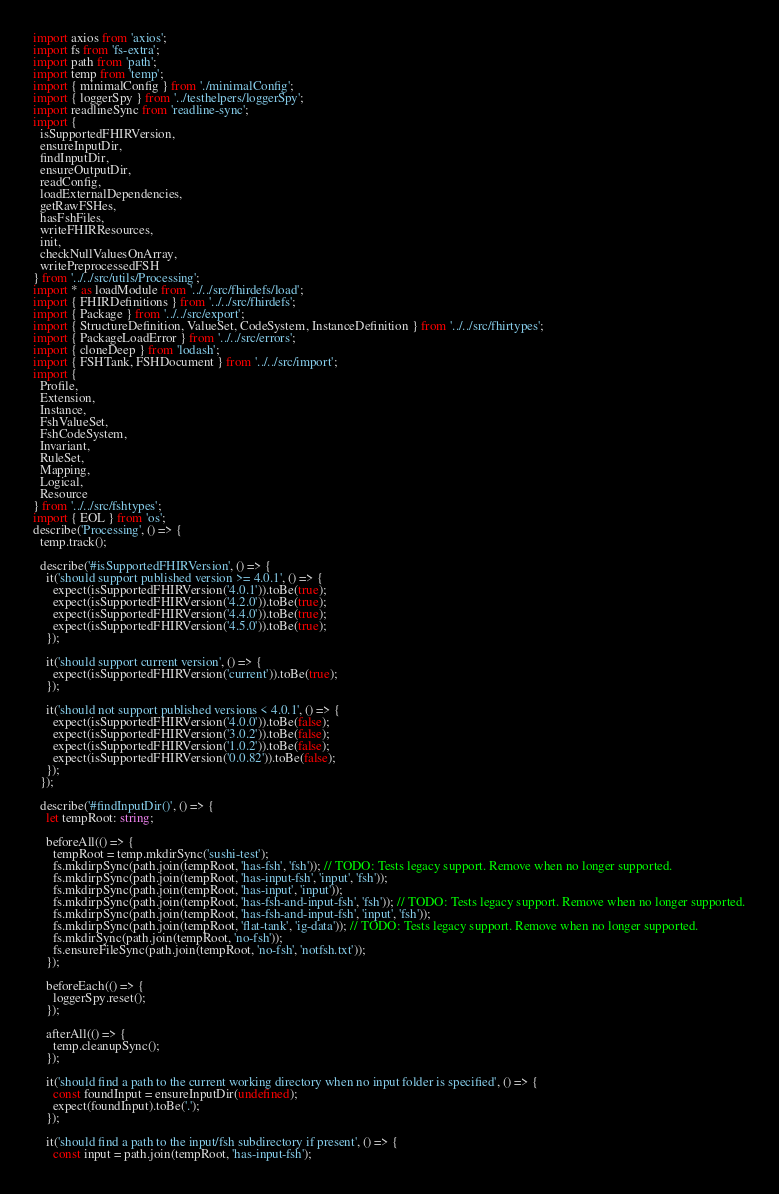<code> <loc_0><loc_0><loc_500><loc_500><_TypeScript_>import axios from 'axios';
import fs from 'fs-extra';
import path from 'path';
import temp from 'temp';
import { minimalConfig } from './minimalConfig';
import { loggerSpy } from '../testhelpers/loggerSpy';
import readlineSync from 'readline-sync';
import {
  isSupportedFHIRVersion,
  ensureInputDir,
  findInputDir,
  ensureOutputDir,
  readConfig,
  loadExternalDependencies,
  getRawFSHes,
  hasFshFiles,
  writeFHIRResources,
  init,
  checkNullValuesOnArray,
  writePreprocessedFSH
} from '../../src/utils/Processing';
import * as loadModule from '../../src/fhirdefs/load';
import { FHIRDefinitions } from '../../src/fhirdefs';
import { Package } from '../../src/export';
import { StructureDefinition, ValueSet, CodeSystem, InstanceDefinition } from '../../src/fhirtypes';
import { PackageLoadError } from '../../src/errors';
import { cloneDeep } from 'lodash';
import { FSHTank, FSHDocument } from '../../src/import';
import {
  Profile,
  Extension,
  Instance,
  FshValueSet,
  FshCodeSystem,
  Invariant,
  RuleSet,
  Mapping,
  Logical,
  Resource
} from '../../src/fshtypes';
import { EOL } from 'os';
describe('Processing', () => {
  temp.track();

  describe('#isSupportedFHIRVersion', () => {
    it('should support published version >= 4.0.1', () => {
      expect(isSupportedFHIRVersion('4.0.1')).toBe(true);
      expect(isSupportedFHIRVersion('4.2.0')).toBe(true);
      expect(isSupportedFHIRVersion('4.4.0')).toBe(true);
      expect(isSupportedFHIRVersion('4.5.0')).toBe(true);
    });

    it('should support current version', () => {
      expect(isSupportedFHIRVersion('current')).toBe(true);
    });

    it('should not support published versions < 4.0.1', () => {
      expect(isSupportedFHIRVersion('4.0.0')).toBe(false);
      expect(isSupportedFHIRVersion('3.0.2')).toBe(false);
      expect(isSupportedFHIRVersion('1.0.2')).toBe(false);
      expect(isSupportedFHIRVersion('0.0.82')).toBe(false);
    });
  });

  describe('#findInputDir()', () => {
    let tempRoot: string;

    beforeAll(() => {
      tempRoot = temp.mkdirSync('sushi-test');
      fs.mkdirpSync(path.join(tempRoot, 'has-fsh', 'fsh')); // TODO: Tests legacy support. Remove when no longer supported.
      fs.mkdirpSync(path.join(tempRoot, 'has-input-fsh', 'input', 'fsh'));
      fs.mkdirpSync(path.join(tempRoot, 'has-input', 'input'));
      fs.mkdirpSync(path.join(tempRoot, 'has-fsh-and-input-fsh', 'fsh')); // TODO: Tests legacy support. Remove when no longer supported.
      fs.mkdirpSync(path.join(tempRoot, 'has-fsh-and-input-fsh', 'input', 'fsh'));
      fs.mkdirpSync(path.join(tempRoot, 'flat-tank', 'ig-data')); // TODO: Tests legacy support. Remove when no longer supported.
      fs.mkdirSync(path.join(tempRoot, 'no-fsh'));
      fs.ensureFileSync(path.join(tempRoot, 'no-fsh', 'notfsh.txt'));
    });

    beforeEach(() => {
      loggerSpy.reset();
    });

    afterAll(() => {
      temp.cleanupSync();
    });

    it('should find a path to the current working directory when no input folder is specified', () => {
      const foundInput = ensureInputDir(undefined);
      expect(foundInput).toBe('.');
    });

    it('should find a path to the input/fsh subdirectory if present', () => {
      const input = path.join(tempRoot, 'has-input-fsh');</code> 